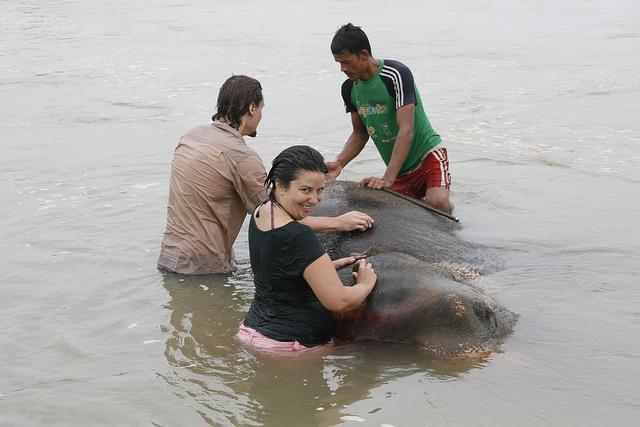How many living beings are in the picture?
Give a very brief answer. 4. How many elephants are in the picture?
Give a very brief answer. 1. How many people are there?
Give a very brief answer. 3. 